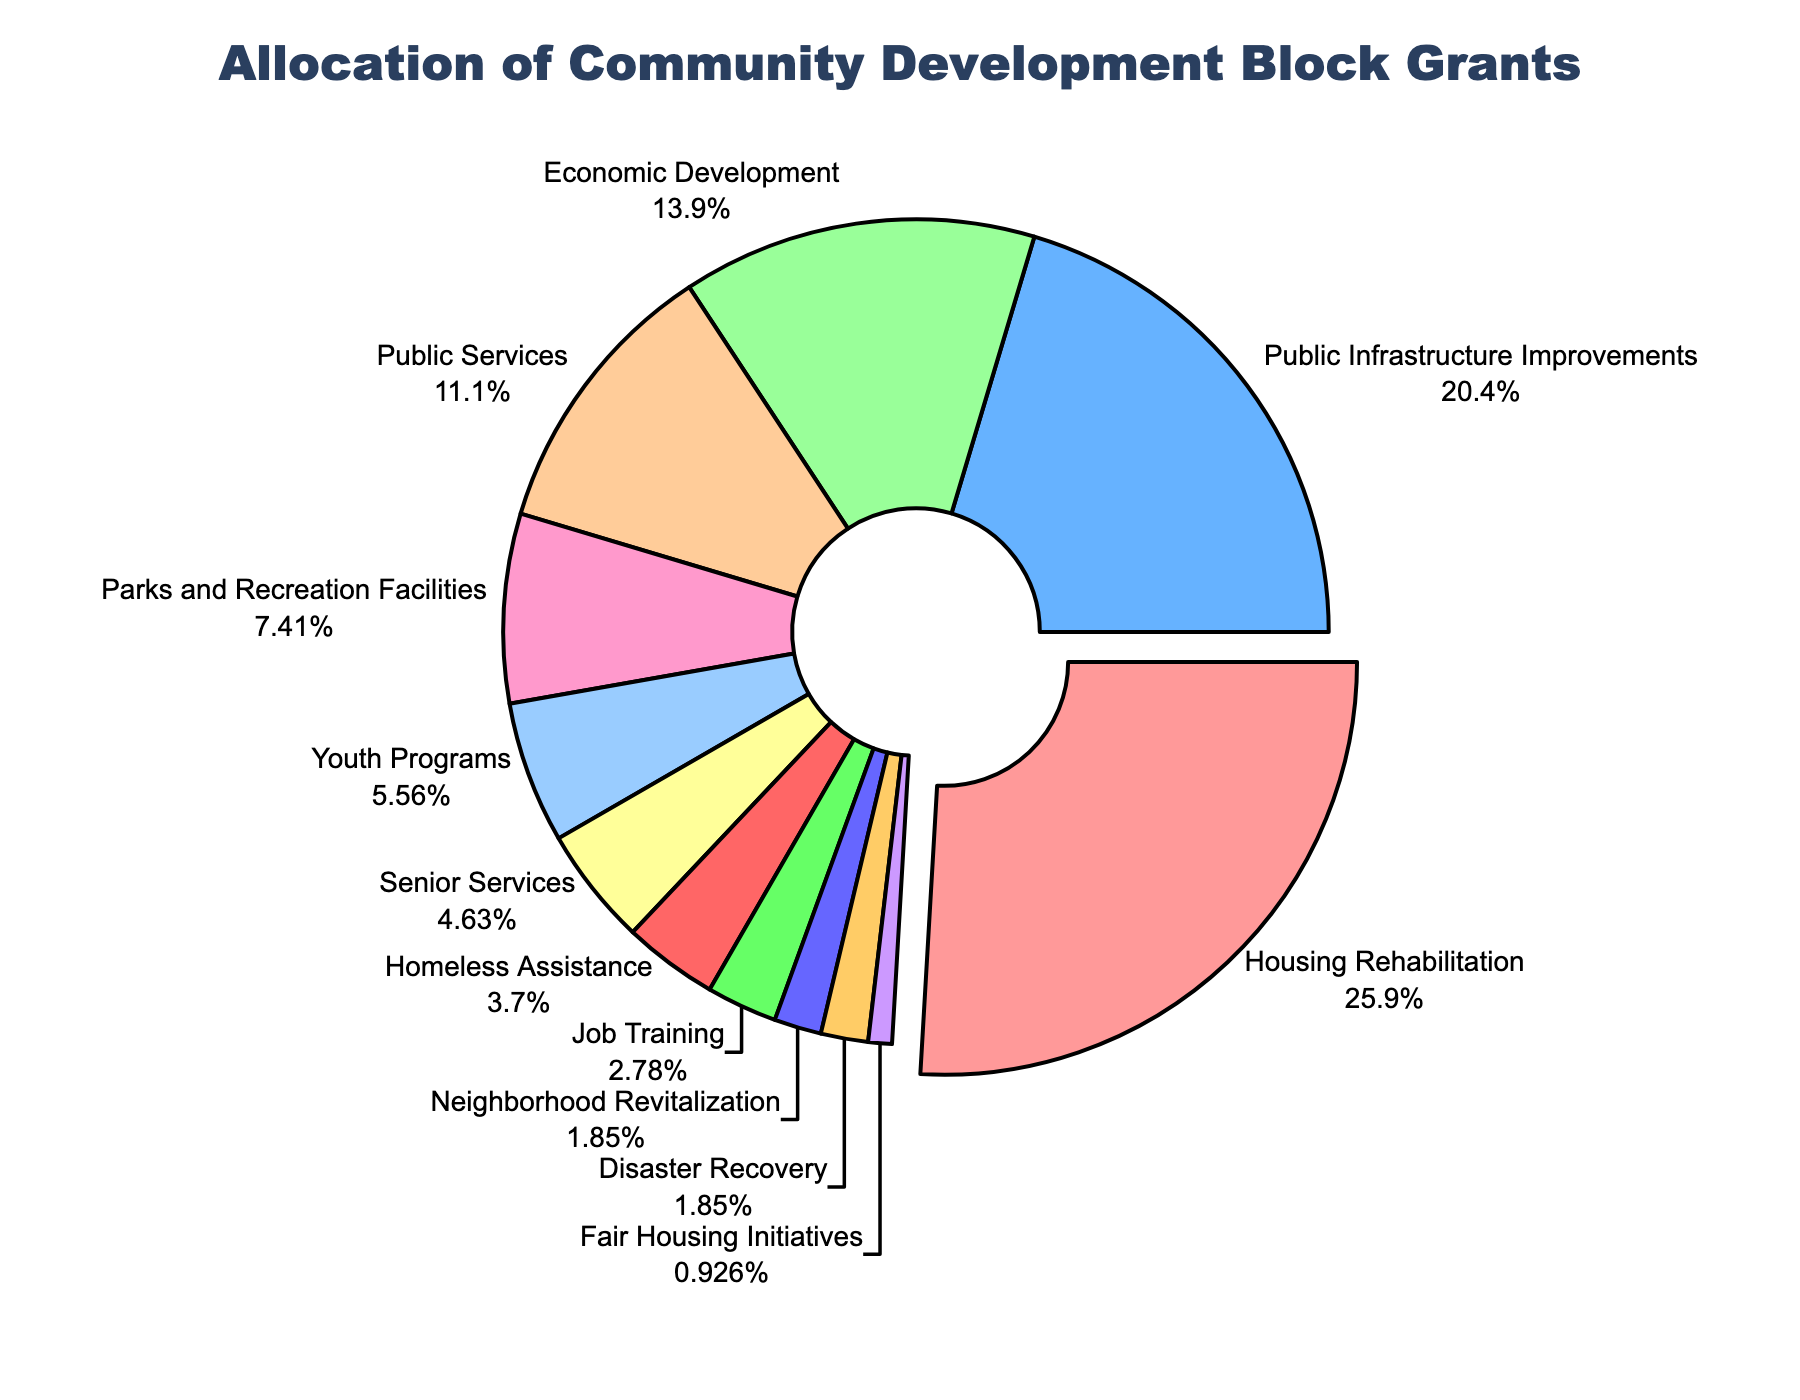what's the largest allocation percentage for a program area? The largest allocation percentage is the slice of the pie chart that is visibly pulled out most. This piece is labeled "Housing Rehabilitation" with 28%.
Answer: 28% what is the total allocation percentage for Youth Programs and Senior Services? The allocation percentage for Youth Programs is 6% and for Senior Services is 5%. Summing them up gives 6% + 5% = 11%.
Answer: 11% which program area has a smaller allocation percentage: Public Services or Economic Development? By comparing the slices for Public Services and Economic Development, we see that Public Services has 12% and Economic Development has 15%. Since 12% is less than 15%, Public Services has a smaller allocation percentage.
Answer: Public Services how many program areas have an allocation percentage less than 5%? The program areas with less than 5% are Homeless Assistance (4%), Job Training (3%), Neighborhood Revitalization (2%), Disaster Recovery (2%), and Fair Housing Initiatives (1%). There are 5 such areas.
Answer: 5 which program areas collectively make up more than half of the total allocation? Start by identifying the largest chunks: Housing Rehabilitation (28%), Public Infrastructure Improvements (22%), and Economic Development (15%). Summing these gives 28% + 22% + 15% = 65%, which is already more than 50%. Therefore, these three areas collectively make up more than half of the total allocation.
Answer: Housing Rehabilitation, Public Infrastructure Improvements, Economic Development what's the dissimilarity in allocation percentages between Parks and Recreation Facilities and Disaster Recovery? Parks and Recreation Facilities have 8% and Disaster Recovery has 2%. Subtracting the smaller percentage from the larger one gives 8% - 2% = 6%.
Answer: 6% which program area is associated with a light green color in the pie chart? By visually inspecting the colors of the slices in the pie chart, the light green color corresponds to Youth Programs, which has an allocation of 6%.
Answer: Youth Programs 